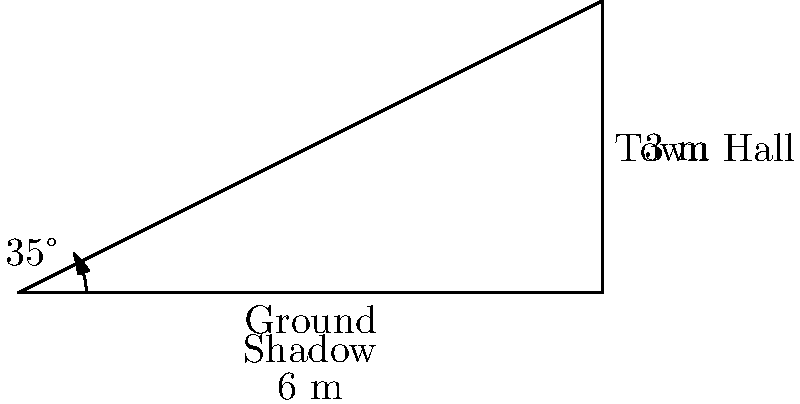The historic Ballarat Town Hall casts a shadow 6 meters long when the sun is at an angle of 35° above the horizon. Using this information, calculate the height of the town hall to the nearest tenth of a meter. To solve this problem, we'll use trigonometry, specifically the tangent function. Let's approach this step-by-step:

1) In a right triangle formed by the town hall, its shadow, and the sun's rays, we know:
   - The angle of elevation of the sun: 35°
   - The length of the shadow: 6 meters
   - We need to find the height of the town hall

2) The tangent of an angle in a right triangle is the ratio of the opposite side to the adjacent side.

3) In this case:
   $\tan(35°) = \frac{\text{height of town hall}}{\text{length of shadow}}$

4) We can express this as an equation:
   $\tan(35°) = \frac{h}{6}$, where $h$ is the height of the town hall

5) To solve for $h$, we multiply both sides by 6:
   $6 \cdot \tan(35°) = h$

6) Now, let's calculate:
   $h = 6 \cdot \tan(35°)$
   $h = 6 \cdot 0.7002075$
   $h = 4.2012450$

7) Rounding to the nearest tenth:
   $h \approx 4.2$ meters

Therefore, the height of the Ballarat Town Hall is approximately 4.2 meters.
Answer: 4.2 meters 